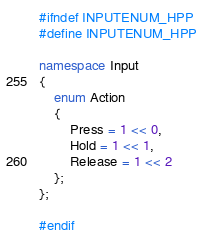<code> <loc_0><loc_0><loc_500><loc_500><_C++_>#ifndef INPUTENUM_HPP
#define INPUTENUM_HPP

namespace Input
{
	enum Action
	{
		Press = 1 << 0,
		Hold = 1 << 1,
		Release = 1 << 2
	};
};

#endif</code> 